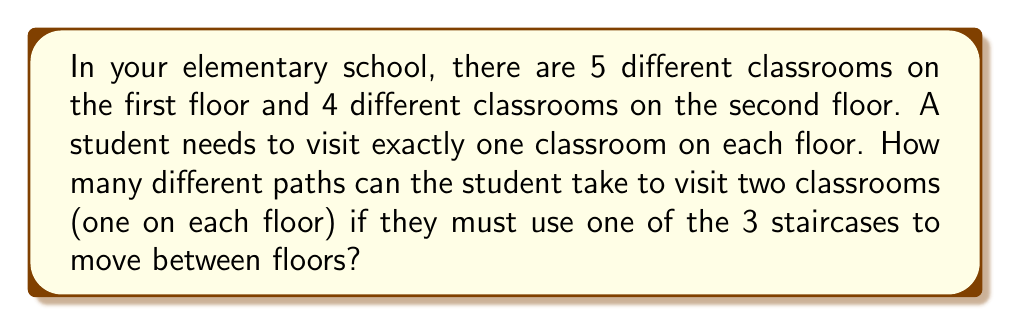Can you solve this math problem? Let's break this down step-by-step:

1) First, let's consider the choices for the first floor:
   - The student can choose any of the 5 classrooms on the first floor.

2) After visiting a classroom on the first floor, the student must use a staircase:
   - There are 3 staircases to choose from.

3) Once on the second floor, the student can choose any of the 4 classrooms:
   - The student has 4 choices for the second floor classroom.

4) To find the total number of possible paths, we use the multiplication principle:
   - For each choice of first floor classroom, staircase, and second floor classroom, we have a unique path.
   - Therefore, we multiply the number of choices for each step:

   $$ \text{Total paths} = 5 \times 3 \times 4 $$

5) Calculating the result:
   $$ \text{Total paths} = 5 \times 3 \times 4 = 60 $$

Thus, there are 60 different paths the student can take.
Answer: 60 paths 